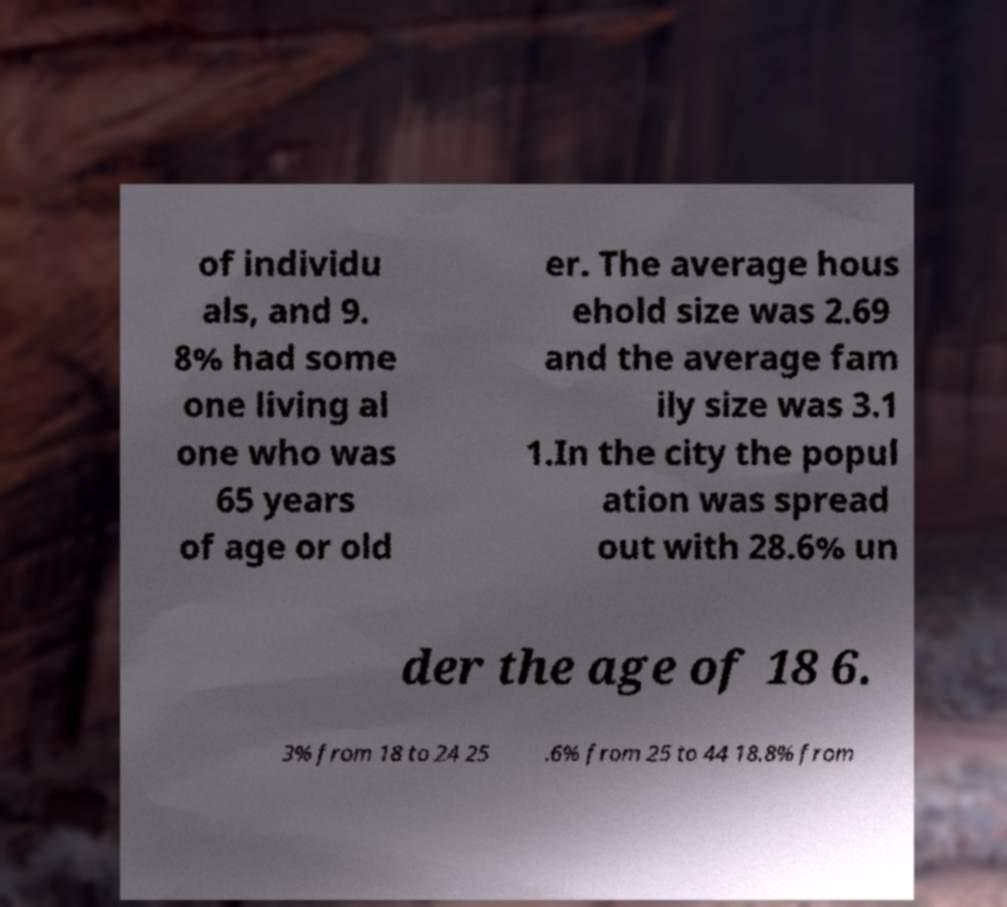Please identify and transcribe the text found in this image. of individu als, and 9. 8% had some one living al one who was 65 years of age or old er. The average hous ehold size was 2.69 and the average fam ily size was 3.1 1.In the city the popul ation was spread out with 28.6% un der the age of 18 6. 3% from 18 to 24 25 .6% from 25 to 44 18.8% from 